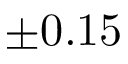<formula> <loc_0><loc_0><loc_500><loc_500>\pm 0 . 1 5</formula> 